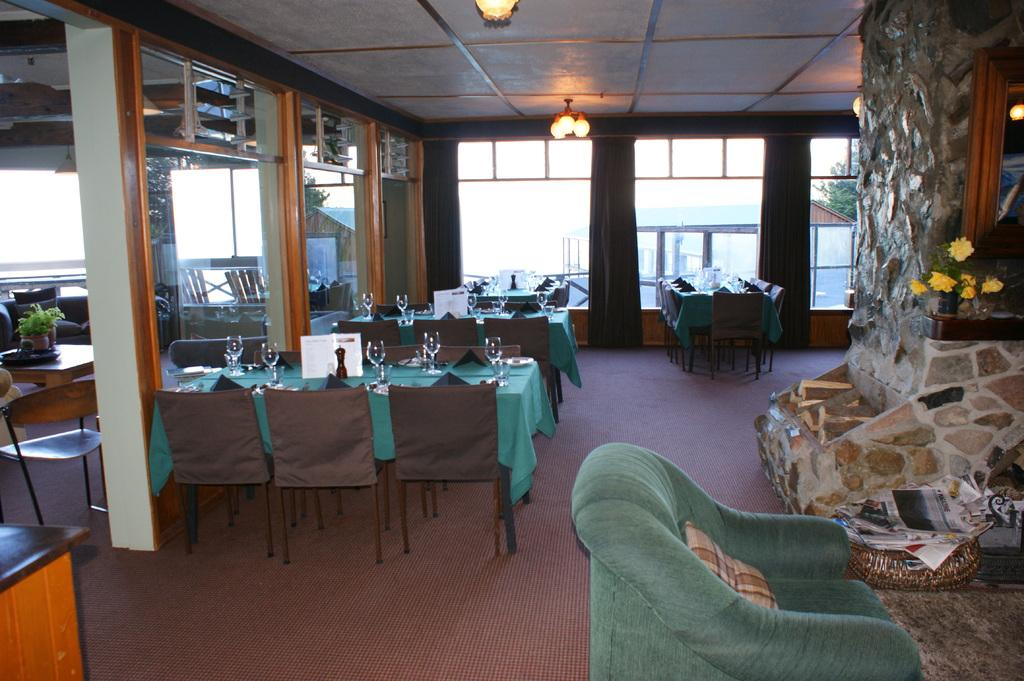What type of establishment is shown in the picture? There is a restaurant in the picture. What furniture is present in the restaurant? There are tables and chairs in the restaurant. What items can be seen on the tables? There are bottles and glasses on the tables. Are there any decorative elements in the restaurant? Yes, there are little plants in the restaurant. What can be seen above the restaurant? There are lights over the roof of the restaurant. What type of game is being played at the restaurant in the image? There is no game being played in the image; it shows a restaurant with tables, chairs, bottles, glasses, little plants, and lights over the roof. 